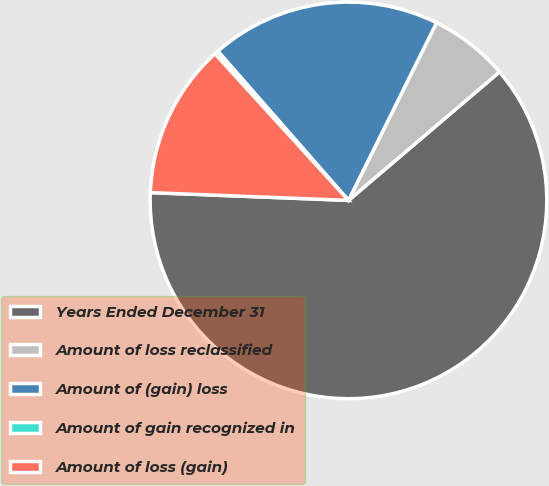Convert chart. <chart><loc_0><loc_0><loc_500><loc_500><pie_chart><fcel>Years Ended December 31<fcel>Amount of loss reclassified<fcel>Amount of (gain) loss<fcel>Amount of gain recognized in<fcel>Amount of loss (gain)<nl><fcel>61.85%<fcel>6.46%<fcel>18.77%<fcel>0.31%<fcel>12.62%<nl></chart> 